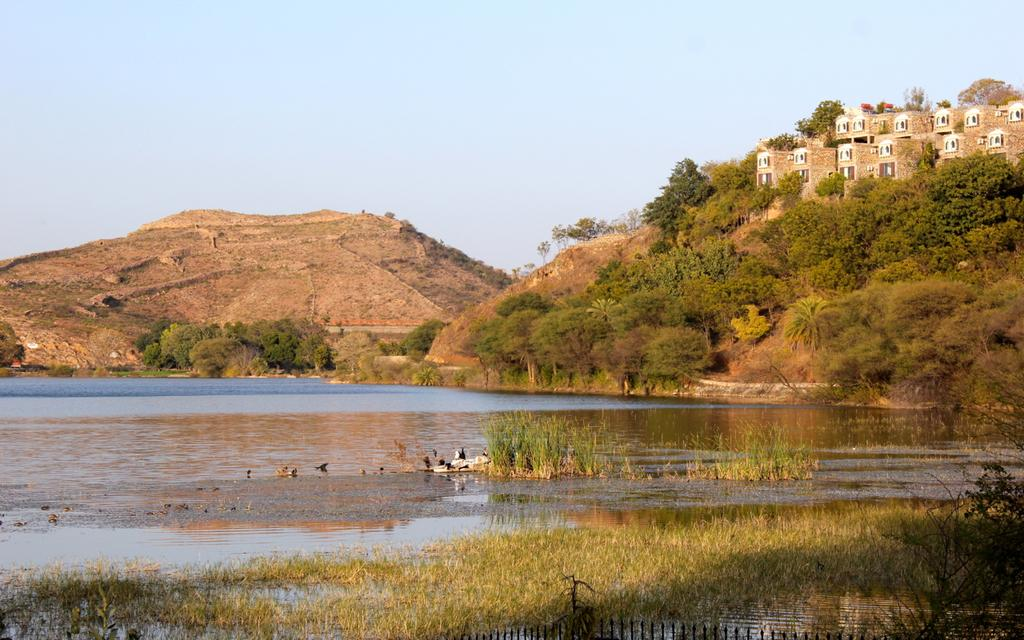What is located in the foreground of the picture? There are birds, plants, and water in the foreground of the picture. What can be seen in the center of the picture? There are hills, buildings, and trees in the center of the picture. What is the condition of the sky in the picture? The sky is clear in the picture. What is the weather like in the image? It is sunny in the image. Can you tell me how many kites are flying in the image? There are no kites present in the image. What type of loaf is being served at the club in the image? There is no club or loaf present in the image. 